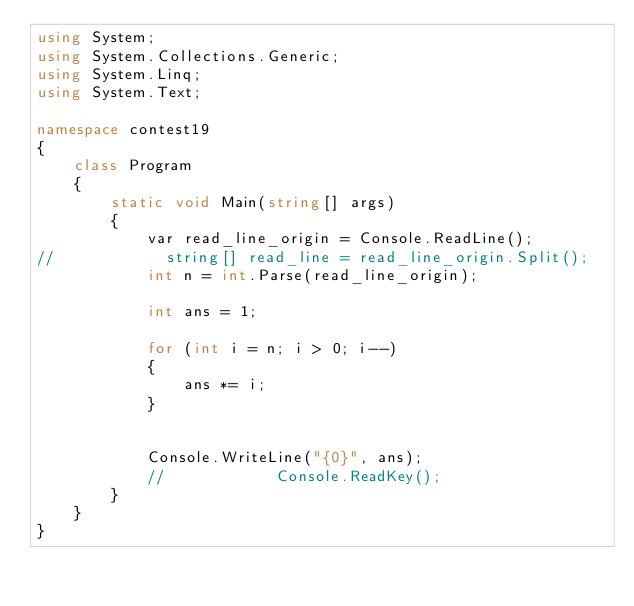Convert code to text. <code><loc_0><loc_0><loc_500><loc_500><_C#_>using System;
using System.Collections.Generic;
using System.Linq;
using System.Text;

namespace contest19
{
    class Program
    {
        static void Main(string[] args)
        {
            var read_line_origin = Console.ReadLine();
//            string[] read_line = read_line_origin.Split();
            int n = int.Parse(read_line_origin);

            int ans = 1;

            for (int i = n; i > 0; i--)
            {
                ans *= i;
            }

            
            Console.WriteLine("{0}", ans);
            //            Console.ReadKey();
        }
    }
}</code> 